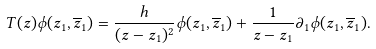Convert formula to latex. <formula><loc_0><loc_0><loc_500><loc_500>T ( z ) \phi ( z _ { 1 } , \overline { z } _ { 1 } ) = \frac { h } { ( z - z _ { 1 } ) ^ { 2 } } \phi ( z _ { 1 } , \overline { z } _ { 1 } ) + \frac { 1 } { z - z _ { 1 } } \partial _ { 1 } \phi ( z _ { 1 } , \overline { z } _ { 1 } ) .</formula> 